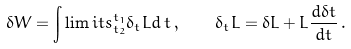<formula> <loc_0><loc_0><loc_500><loc_500>\delta W = \int \lim i t s _ { t _ { 2 } } ^ { t _ { 1 } } \delta _ { t } L d \, t \, , \quad \delta _ { t } L = \delta L + L \frac { d \delta t } { d t } \, .</formula> 